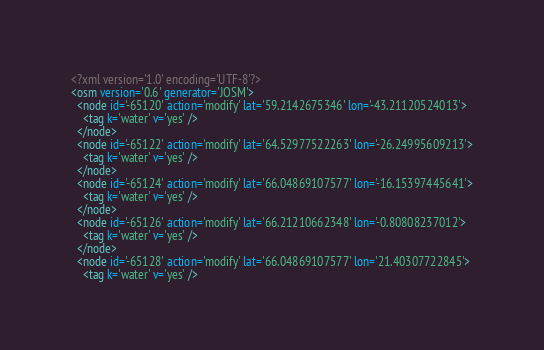<code> <loc_0><loc_0><loc_500><loc_500><_XML_><?xml version='1.0' encoding='UTF-8'?>
<osm version='0.6' generator='JOSM'>
  <node id='-65120' action='modify' lat='59.2142675346' lon='-43.21120524013'>
    <tag k='water' v='yes' />
  </node>
  <node id='-65122' action='modify' lat='64.52977522263' lon='-26.24995609213'>
    <tag k='water' v='yes' />
  </node>
  <node id='-65124' action='modify' lat='66.04869107577' lon='-16.15397445641'>
    <tag k='water' v='yes' />
  </node>
  <node id='-65126' action='modify' lat='66.21210662348' lon='-0.80808237012'>
    <tag k='water' v='yes' />
  </node>
  <node id='-65128' action='modify' lat='66.04869107577' lon='21.40307722845'>
    <tag k='water' v='yes' /></code> 